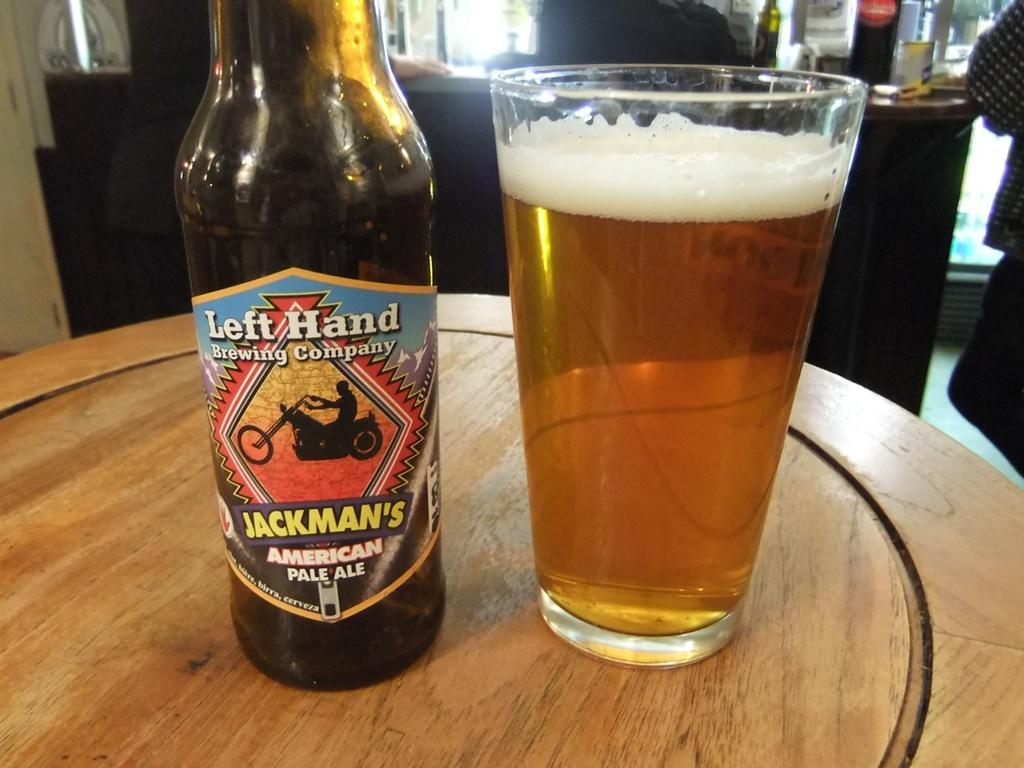<image>
Relay a brief, clear account of the picture shown. A bottle of beer from Left Hand Brewing company next to a glass. 